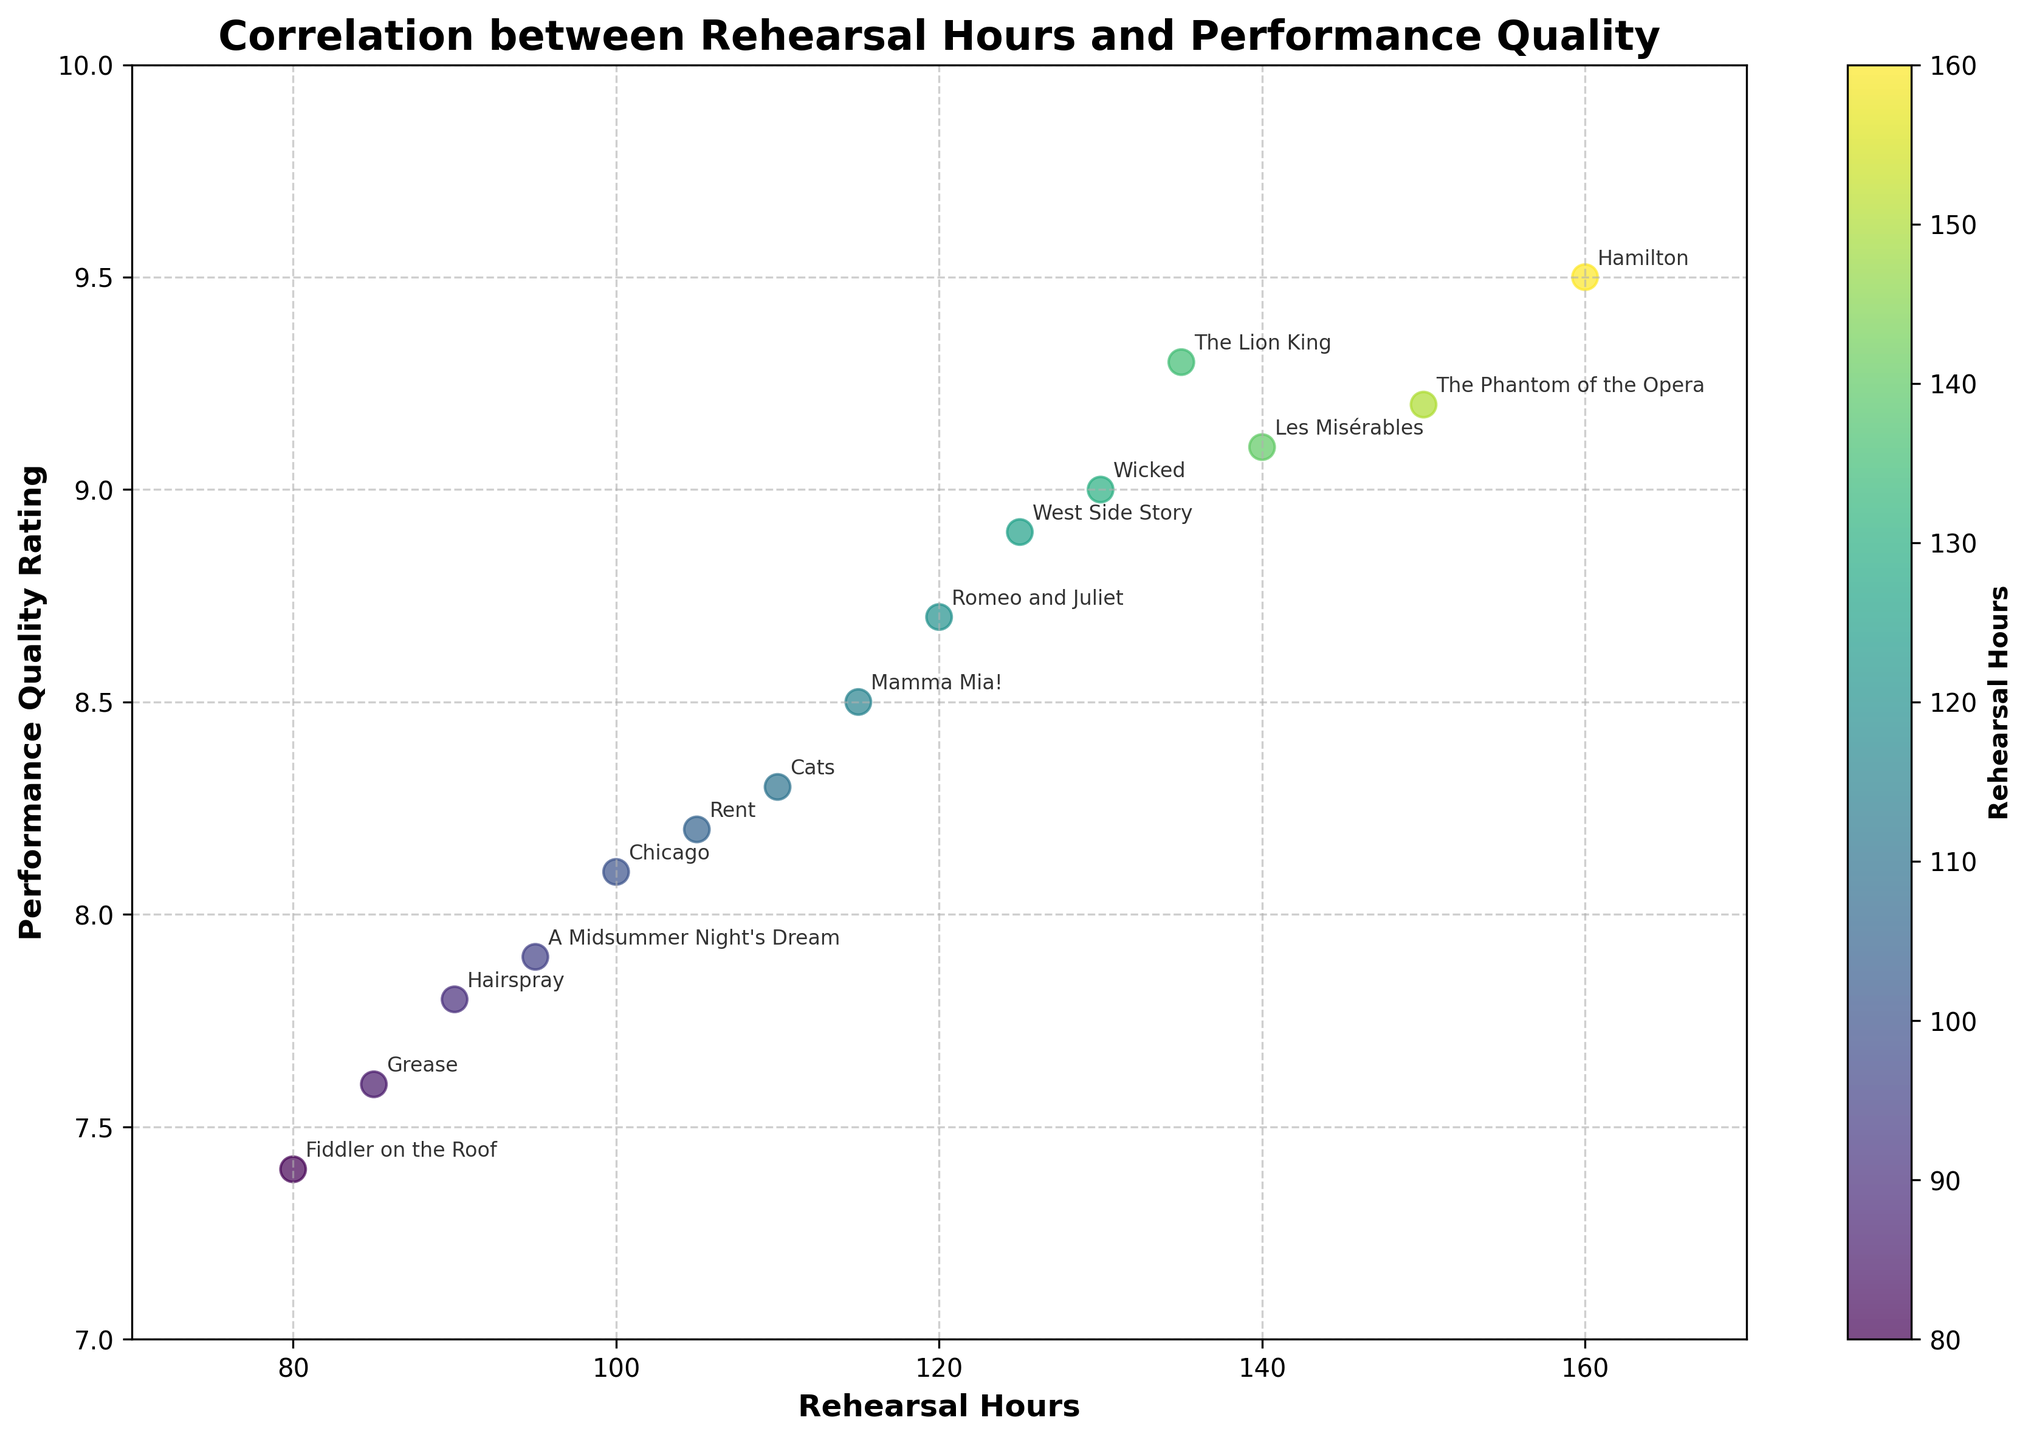How many productions have a rehearsal time of more than 100 hours? To answer this, count the data points (productions) in the scatter plot with Rehearsal Hours greater than 100. There are points at 105, 110, 115, 120, 125, 130, 135, 140, 150, and 160 hours.
Answer: 10 Which production had the highest Performance Quality Rating? Look for the production label at the highest y-axis value. The highest rating is 9.5, and the production associated with this point is Hamilton.
Answer: Hamilton What is the range of Performance Quality Ratings shown in the plot? Identify the minimum and maximum values on the y-axis. The minimum rating is 7.4 (Fiddler on the Roof) and the maximum is 9.5 (Hamilton). The range is 9.5 - 7.4.
Answer: 2.1 Is there any apparent correlation between Rehearsal Hours and Performance Quality Rating? To determine this, observe how the data points are distributed. If the points generally trend upwards, it suggests a positive correlation. In this plot, an upward trend indicates that more rehearsal hours tend to result in higher performance quality ratings.
Answer: Yes, positive correlation Which production had the lowest rehearsal hours and what was its performance rating? Identify the production with the lowest x-axis value. The lowest rehearsal hour value is 80, associated with Fiddler on the Roof, and its performance rating is 7.4.
Answer: Fiddler on the Roof, 7.4 What is the general trend of the scatter plot from left to right? Observe the pattern formed by the points as you move from the left side (lower rehearsal hours) to the right side (higher rehearsal hours). The trend seems to be increasing as rehearsal hours increase.
Answer: Increasing trend How many productions were there with Performance Quality Ratings above 9.0? Count the points that have Performance Quality Ratings greater than 9.0. Those are The Phantom of the Opera, Wicked, Les Misérables, Hamilton, and The Lion King.
Answer: 5 What can be inferred about productions with rehearsal hours between 100 and 120 hours? Look at the points between Rehearsal Hours of 100 and 120. Chicago, Rent, Cats, Mamma Mia!, and Romeo and Juliet fall within this range with a performance quality of 8.1, 8.2, 8.3, 8.5, and 8.7 respectively. They generally have above-average performance ratings.
Answer: They generally have above-average performance ratings 